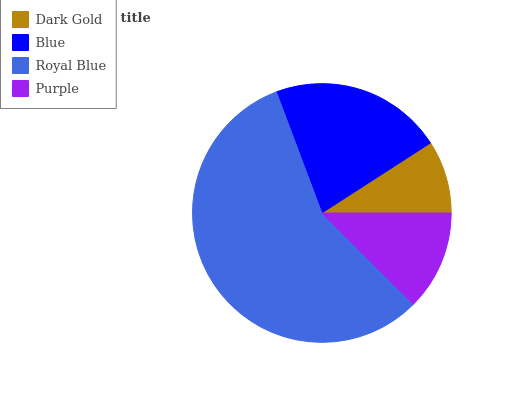Is Dark Gold the minimum?
Answer yes or no. Yes. Is Royal Blue the maximum?
Answer yes or no. Yes. Is Blue the minimum?
Answer yes or no. No. Is Blue the maximum?
Answer yes or no. No. Is Blue greater than Dark Gold?
Answer yes or no. Yes. Is Dark Gold less than Blue?
Answer yes or no. Yes. Is Dark Gold greater than Blue?
Answer yes or no. No. Is Blue less than Dark Gold?
Answer yes or no. No. Is Blue the high median?
Answer yes or no. Yes. Is Purple the low median?
Answer yes or no. Yes. Is Dark Gold the high median?
Answer yes or no. No. Is Dark Gold the low median?
Answer yes or no. No. 